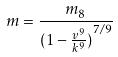Convert formula to latex. <formula><loc_0><loc_0><loc_500><loc_500>m = \frac { m _ { 8 } } { ( { 1 - \frac { v ^ { 9 } } { k ^ { 9 } } ) } ^ { 7 / 9 } }</formula> 